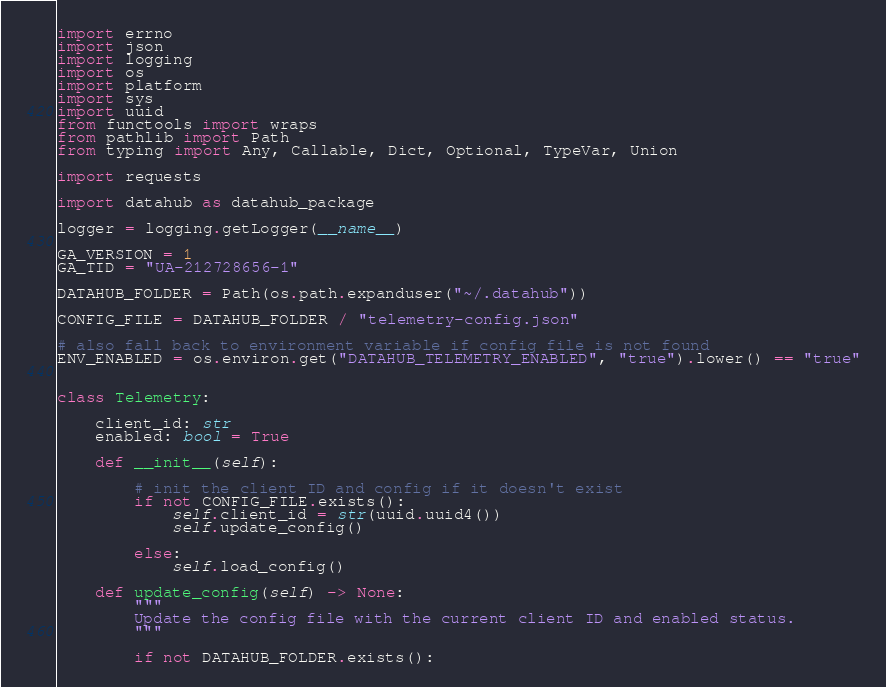Convert code to text. <code><loc_0><loc_0><loc_500><loc_500><_Python_>import errno
import json
import logging
import os
import platform
import sys
import uuid
from functools import wraps
from pathlib import Path
from typing import Any, Callable, Dict, Optional, TypeVar, Union

import requests

import datahub as datahub_package

logger = logging.getLogger(__name__)

GA_VERSION = 1
GA_TID = "UA-212728656-1"

DATAHUB_FOLDER = Path(os.path.expanduser("~/.datahub"))

CONFIG_FILE = DATAHUB_FOLDER / "telemetry-config.json"

# also fall back to environment variable if config file is not found
ENV_ENABLED = os.environ.get("DATAHUB_TELEMETRY_ENABLED", "true").lower() == "true"


class Telemetry:

    client_id: str
    enabled: bool = True

    def __init__(self):

        # init the client ID and config if it doesn't exist
        if not CONFIG_FILE.exists():
            self.client_id = str(uuid.uuid4())
            self.update_config()

        else:
            self.load_config()

    def update_config(self) -> None:
        """
        Update the config file with the current client ID and enabled status.
        """

        if not DATAHUB_FOLDER.exists():</code> 